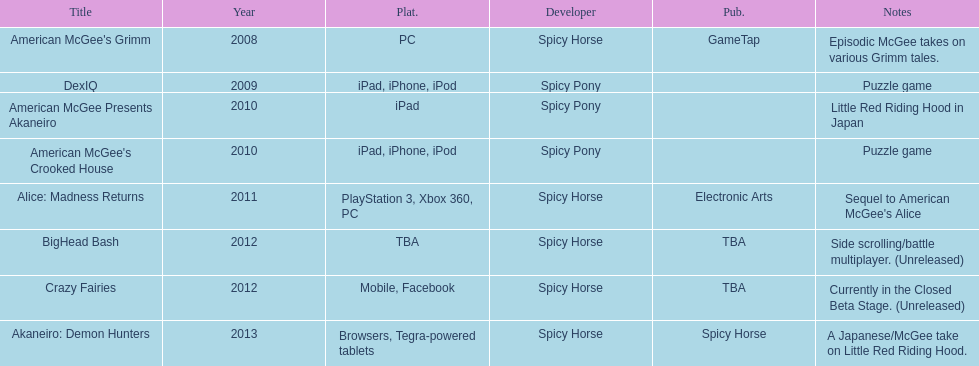How many games did spicy horse develop in total? 5. 